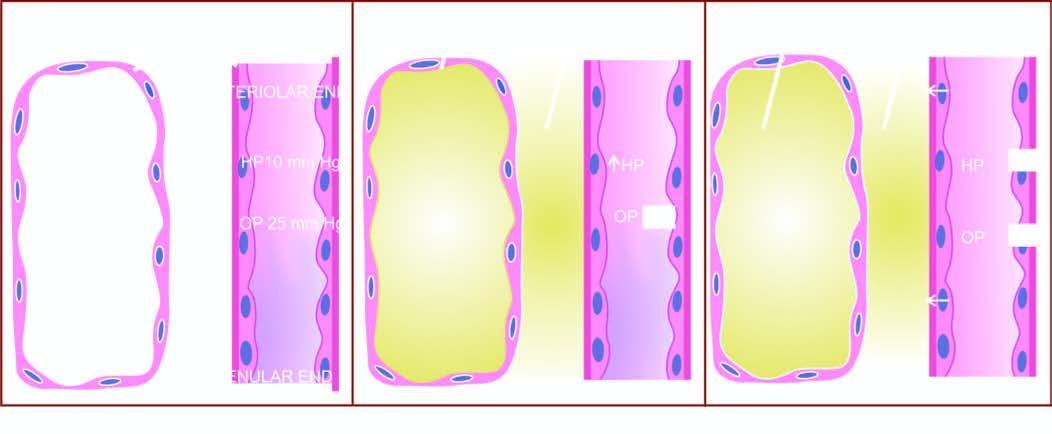what are involved in the pathogenesis of pulmonary oedema?
Answer the question using a single word or phrase. Mechanisms 